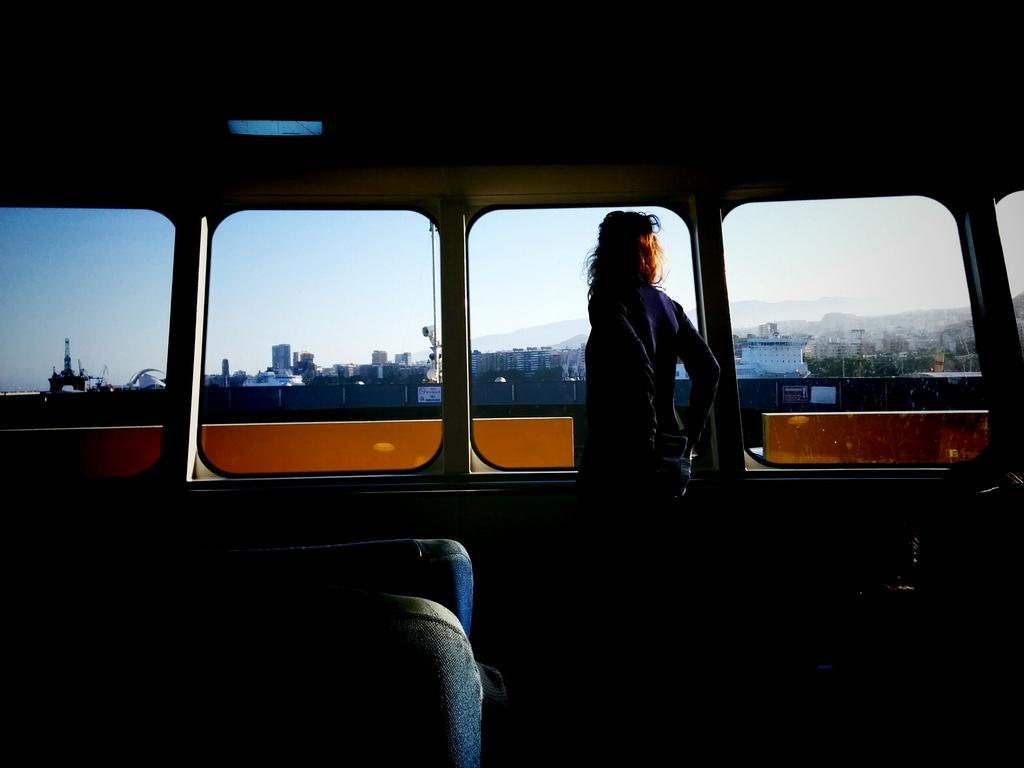Please provide a concise description of this image. In the middle of the image a person is standing in the vehicle and there are some glass windows. Through the glass windows we can see some buildings and clouds and sky. 